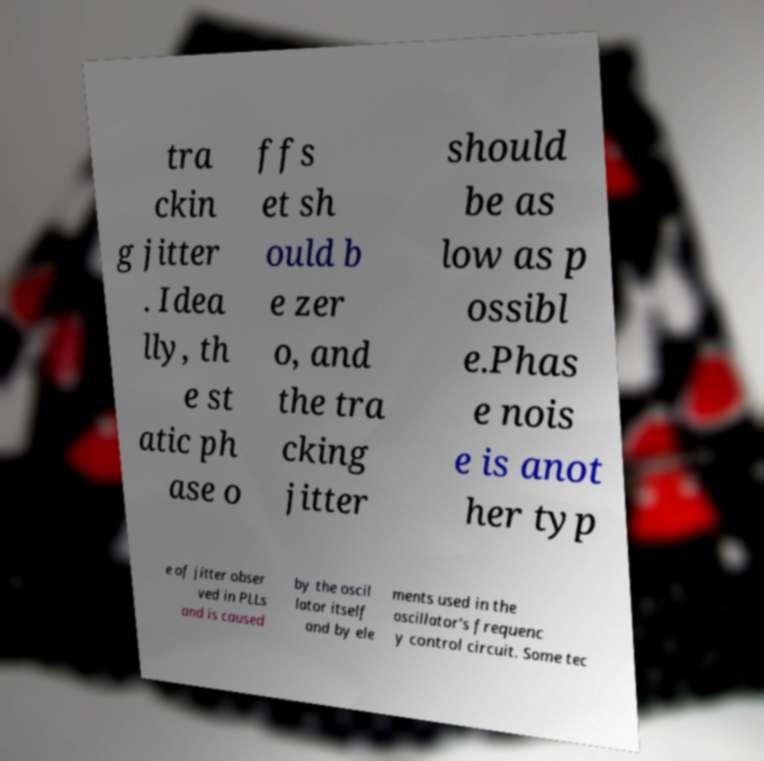For documentation purposes, I need the text within this image transcribed. Could you provide that? tra ckin g jitter . Idea lly, th e st atic ph ase o ffs et sh ould b e zer o, and the tra cking jitter should be as low as p ossibl e.Phas e nois e is anot her typ e of jitter obser ved in PLLs and is caused by the oscil lator itself and by ele ments used in the oscillator's frequenc y control circuit. Some tec 